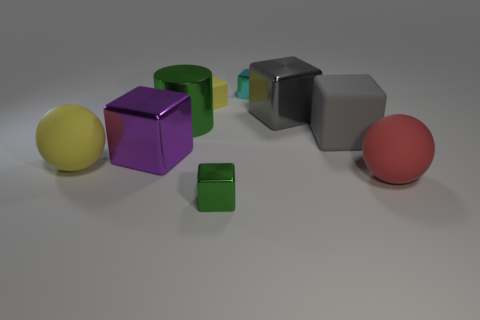What time of day or setting does the lighting in the image suggest? The lighting in the image appears artificial, suggesting an indoor setting with directed light sources. There are soft shadows being cast by each object, which indicates a diffuse light, likely from overhead sources. This kind of controlled lighting is typical of a studio or an indoor photographic environment, rather than any particular time of day. 